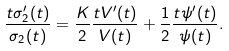Convert formula to latex. <formula><loc_0><loc_0><loc_500><loc_500>\frac { t \sigma _ { 2 } ^ { \prime } ( t ) } { \sigma _ { 2 } ( t ) } = \frac { K } { 2 } \frac { t V ^ { \prime } ( t ) } { V ( t ) } + \frac { 1 } { 2 } \frac { t \psi ^ { \prime } ( t ) } { \psi ( t ) } .</formula> 